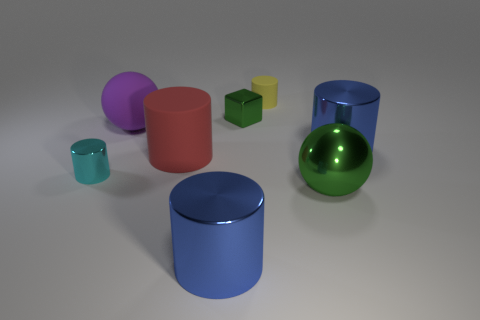How many large green balls are made of the same material as the large purple ball?
Your response must be concise. 0. Does the cube have the same size as the yellow rubber cylinder?
Your answer should be compact. Yes. Is there any other thing of the same color as the tiny rubber thing?
Your answer should be compact. No. What shape is the large object that is both right of the red matte cylinder and on the left side of the small yellow matte cylinder?
Offer a terse response. Cylinder. How big is the cyan cylinder to the left of the tiny yellow cylinder?
Offer a terse response. Small. There is a blue cylinder that is in front of the large metallic thing right of the green ball; how many things are to the right of it?
Your response must be concise. 4. Are there any tiny cylinders right of the big green object?
Provide a succinct answer. No. What number of other things are there of the same size as the green ball?
Ensure brevity in your answer.  4. What material is the big cylinder that is left of the yellow thing and behind the big green metal thing?
Provide a short and direct response. Rubber. There is a big metallic thing that is left of the big green sphere; does it have the same shape as the small metallic object that is to the right of the large red object?
Keep it short and to the point. No. 